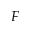Convert formula to latex. <formula><loc_0><loc_0><loc_500><loc_500>F</formula> 